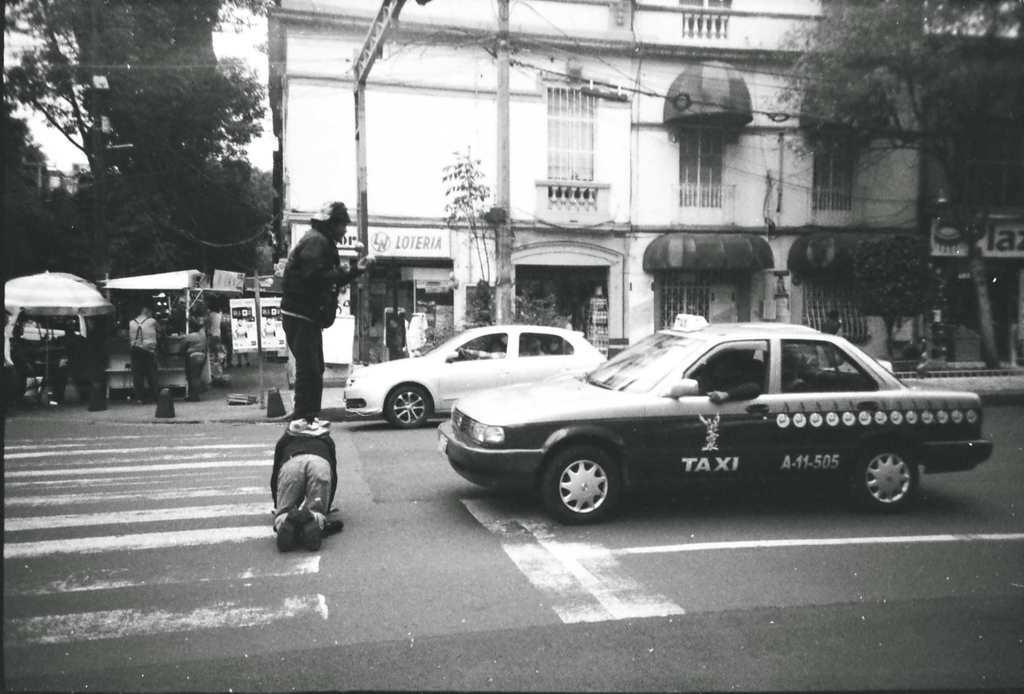<image>
Provide a brief description of the given image. A man is standing on the back of another man in the street and blocking a car that says Taxi. 